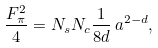Convert formula to latex. <formula><loc_0><loc_0><loc_500><loc_500>\frac { F _ { \pi } ^ { 2 } } { 4 } = N _ { s } N _ { c } \frac { 1 } { 8 d } \, a ^ { 2 - d } ,</formula> 